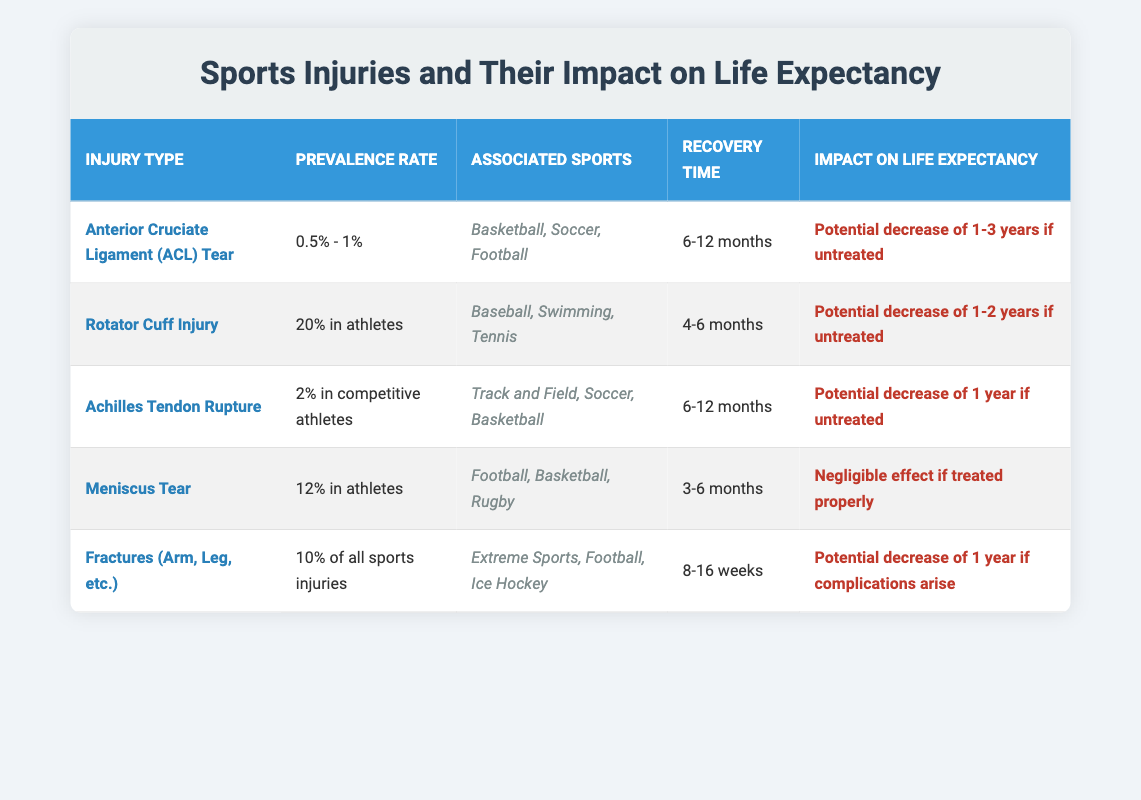What is the recovery time for an Anterior Cruciate Ligament (ACL) Tear? The table shows that the recovery time for an ACL Tear is stated as 6-12 months. This information is directly retrieved from the corresponding cell in the table.
Answer: 6-12 months Which sports are associated with a Rotator Cuff Injury? The table lists Baseball, Swimming, and Tennis as the associated sports for Rotator Cuff Injury. This information can be found in the cell under "Associated Sports" for this injury type.
Answer: Baseball, Swimming, Tennis Does a Meniscus Tear have a significant impact on life expectancy if treated properly? The table indicates that a Meniscus Tear has a "Negligible effect if treated properly" on life expectancy, thus confirming that it does not significantly affect longevity when properly managed.
Answer: Yes What is the potential decrease in life expectancy for untreated Rotator Cuff injuries? According to the table, the impact of untreated Rotator Cuff injuries can decrease life expectancy by "1-2 years." This value is directly referenced from the impact column associated with this injury type.
Answer: 1-2 years How many types of injuries have a potential decrease in life expectancy exceeding 1 year if untreated? By examining the impact column in the table, three injuries (ACL Tear, Rotator Cuff Injury, and Achilles Tendon Rupture) show a potential decrease in life expectancy by at least 1 year (ACL: 1-3 years, Rotator Cuff: 1-2 years, Achilles: 1 year).
Answer: 3 What is the prevalence rate of Meniscus Tears in athletes compared to the prevalence rate of Achille’s Tendon Rupture? The table states that Meniscus Tears have a prevalence rate of "12% in athletes," while Achilles Tendon Rupture has a prevalence rate of "2% in competitive athletes." Thus, Meniscus Tears are more prevalent in athletes than Achille’s Tendon Rupture.
Answer: Meniscus Tears are more prevalent What is the average recovery time for all injuries listed in the table? To find the average recovery time, one must first convert each recovery time into a numerical value to calculate the average. The recovery times are 6-12 months (average = 9 months), 4-6 months (average = 5 months), 6-12 months (average = 9 months), 3-6 months (average = 4.5 months), and 8-16 weeks (average = 12 weeks or 3 months). Converting all to months gives an average recovery of (9 + 5 + 9 + 4.5 + 3) / 5 = 6.1 months.
Answer: 6.1 months 